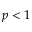Convert formula to latex. <formula><loc_0><loc_0><loc_500><loc_500>p < 1</formula> 